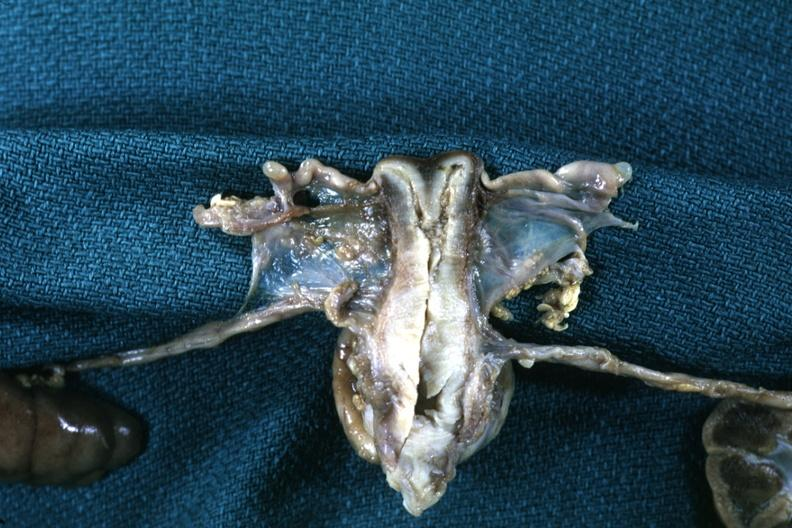s cervix duplication present?
Answer the question using a single word or phrase. Yes 